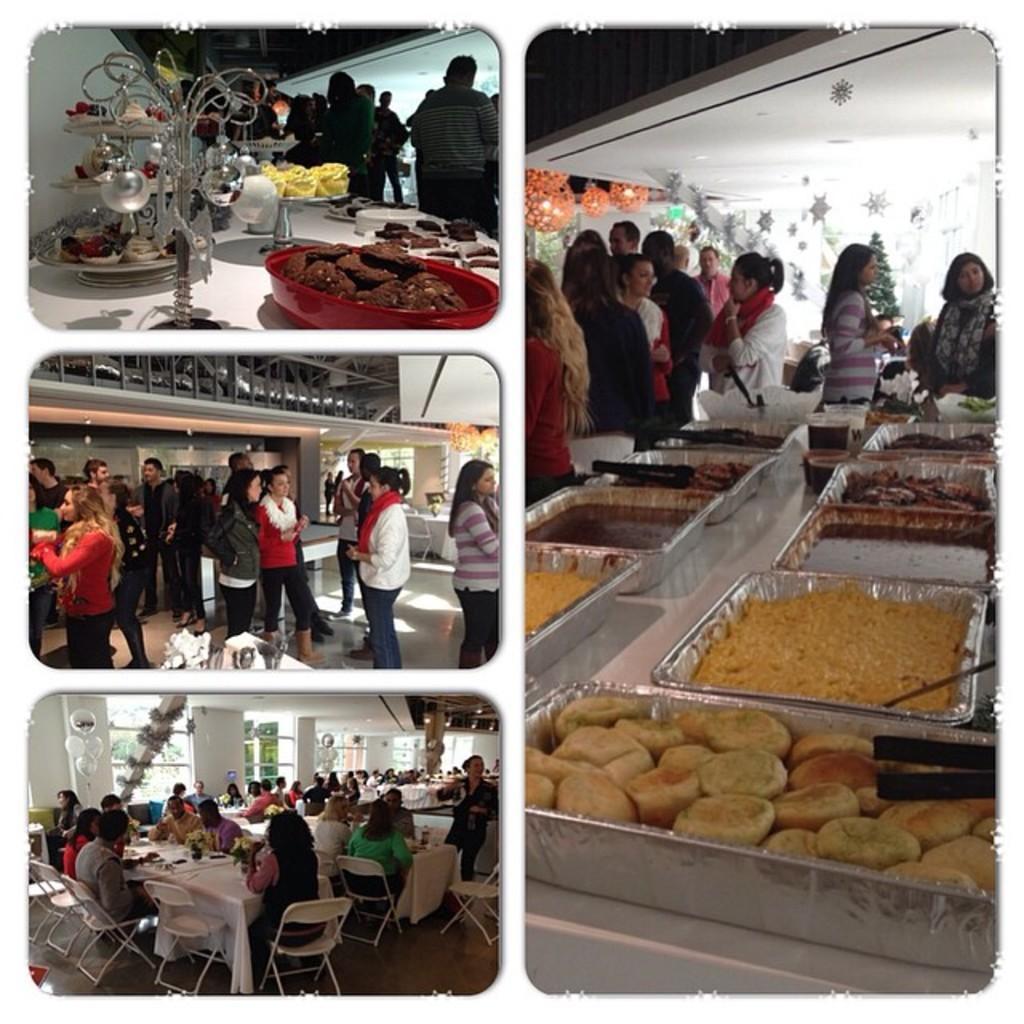How would you summarize this image in a sentence or two? This picture is a collage of 4 images. The image on the right side consists of food and the persons are standing. The image on the left side at the top consists of food and there are persons standing and image in the center consist of persons standing and there is a table covered with white colour cloth and image at the bottom consists of persons sitting and standing and there are tables and there are windows. 